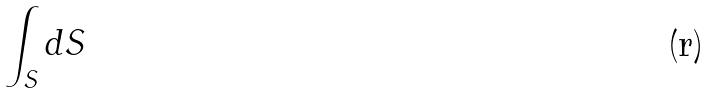<formula> <loc_0><loc_0><loc_500><loc_500>\int _ { S } d S</formula> 